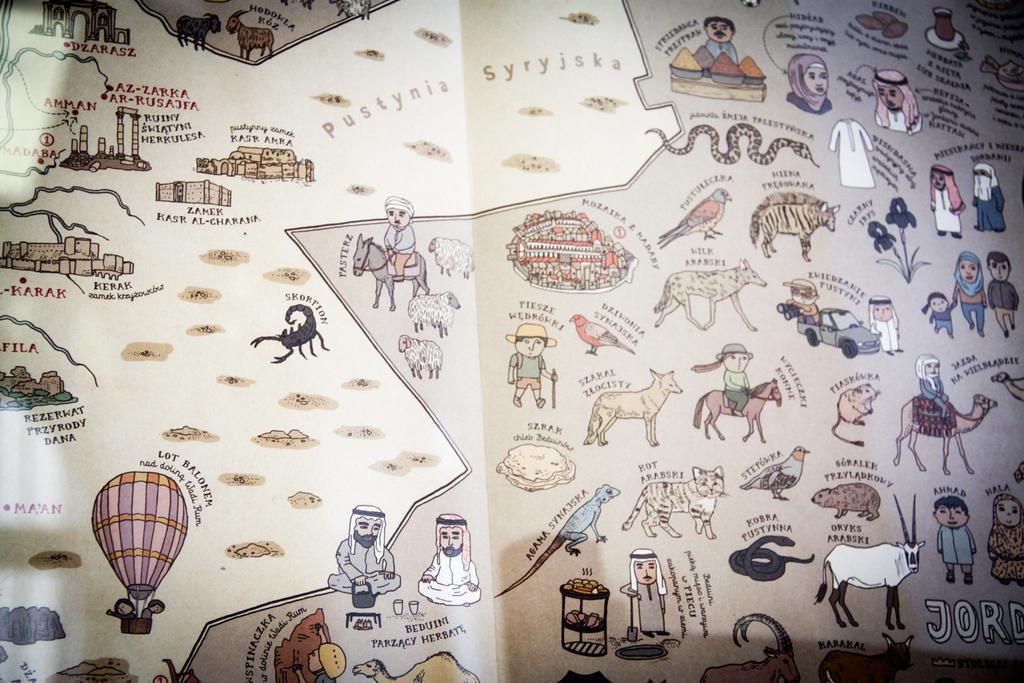Describe this image in one or two sentences. There is a poster having animated images of persons, animals, birds, buildings and other objects. And there are texts on this poster. 